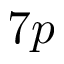Convert formula to latex. <formula><loc_0><loc_0><loc_500><loc_500>7 p</formula> 